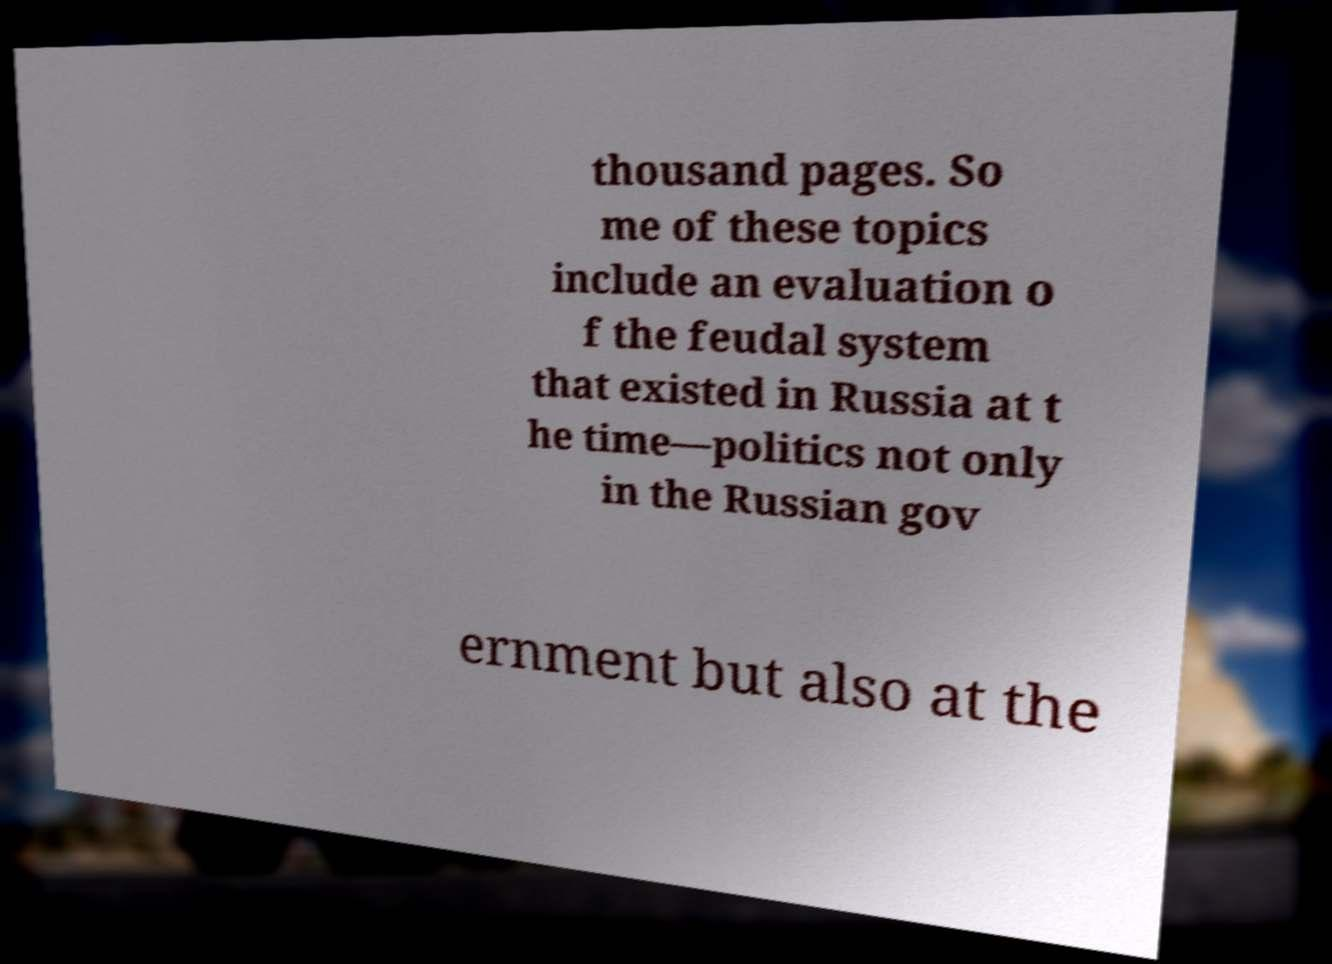Can you accurately transcribe the text from the provided image for me? thousand pages. So me of these topics include an evaluation o f the feudal system that existed in Russia at t he time—politics not only in the Russian gov ernment but also at the 